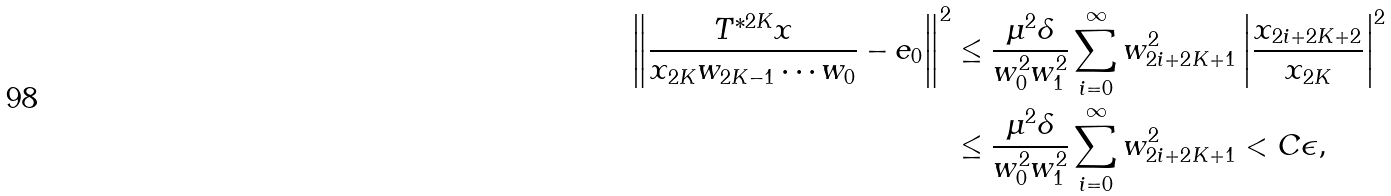Convert formula to latex. <formula><loc_0><loc_0><loc_500><loc_500>\left \| \frac { T ^ { * 2 K } x } { x _ { 2 K } w _ { 2 K - 1 } \cdots w _ { 0 } } - e _ { 0 } \right \| ^ { 2 } & \leq \frac { \mu ^ { 2 } \delta } { w _ { 0 } ^ { 2 } w _ { 1 } ^ { 2 } } \sum _ { i = 0 } ^ { \infty } w _ { 2 i + 2 K + 1 } ^ { 2 } \left | \frac { x _ { 2 i + 2 K + 2 } } { x _ { 2 K } } \right | ^ { 2 } \\ & \leq \frac { \mu ^ { 2 } \delta } { w _ { 0 } ^ { 2 } w _ { 1 } ^ { 2 } } \sum _ { i = 0 } ^ { \infty } w _ { 2 i + 2 K + 1 } ^ { 2 } < C \epsilon ,</formula> 